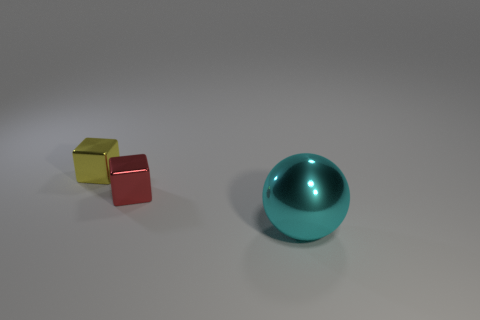Subtract all red blocks. How many blocks are left? 1 Subtract 1 spheres. How many spheres are left? 0 Subtract all cyan cylinders. How many gray spheres are left? 0 Subtract all small green cylinders. Subtract all cyan shiny balls. How many objects are left? 2 Add 1 tiny red things. How many tiny red things are left? 2 Add 3 yellow cubes. How many yellow cubes exist? 4 Add 3 metal blocks. How many objects exist? 6 Subtract 0 gray blocks. How many objects are left? 3 Subtract all balls. How many objects are left? 2 Subtract all yellow balls. Subtract all blue cylinders. How many balls are left? 1 